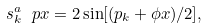<formula> <loc_0><loc_0><loc_500><loc_500>s ^ { a } _ { k } \ p x = 2 \sin [ ( p _ { k } + \phi x ) / 2 ] ,</formula> 